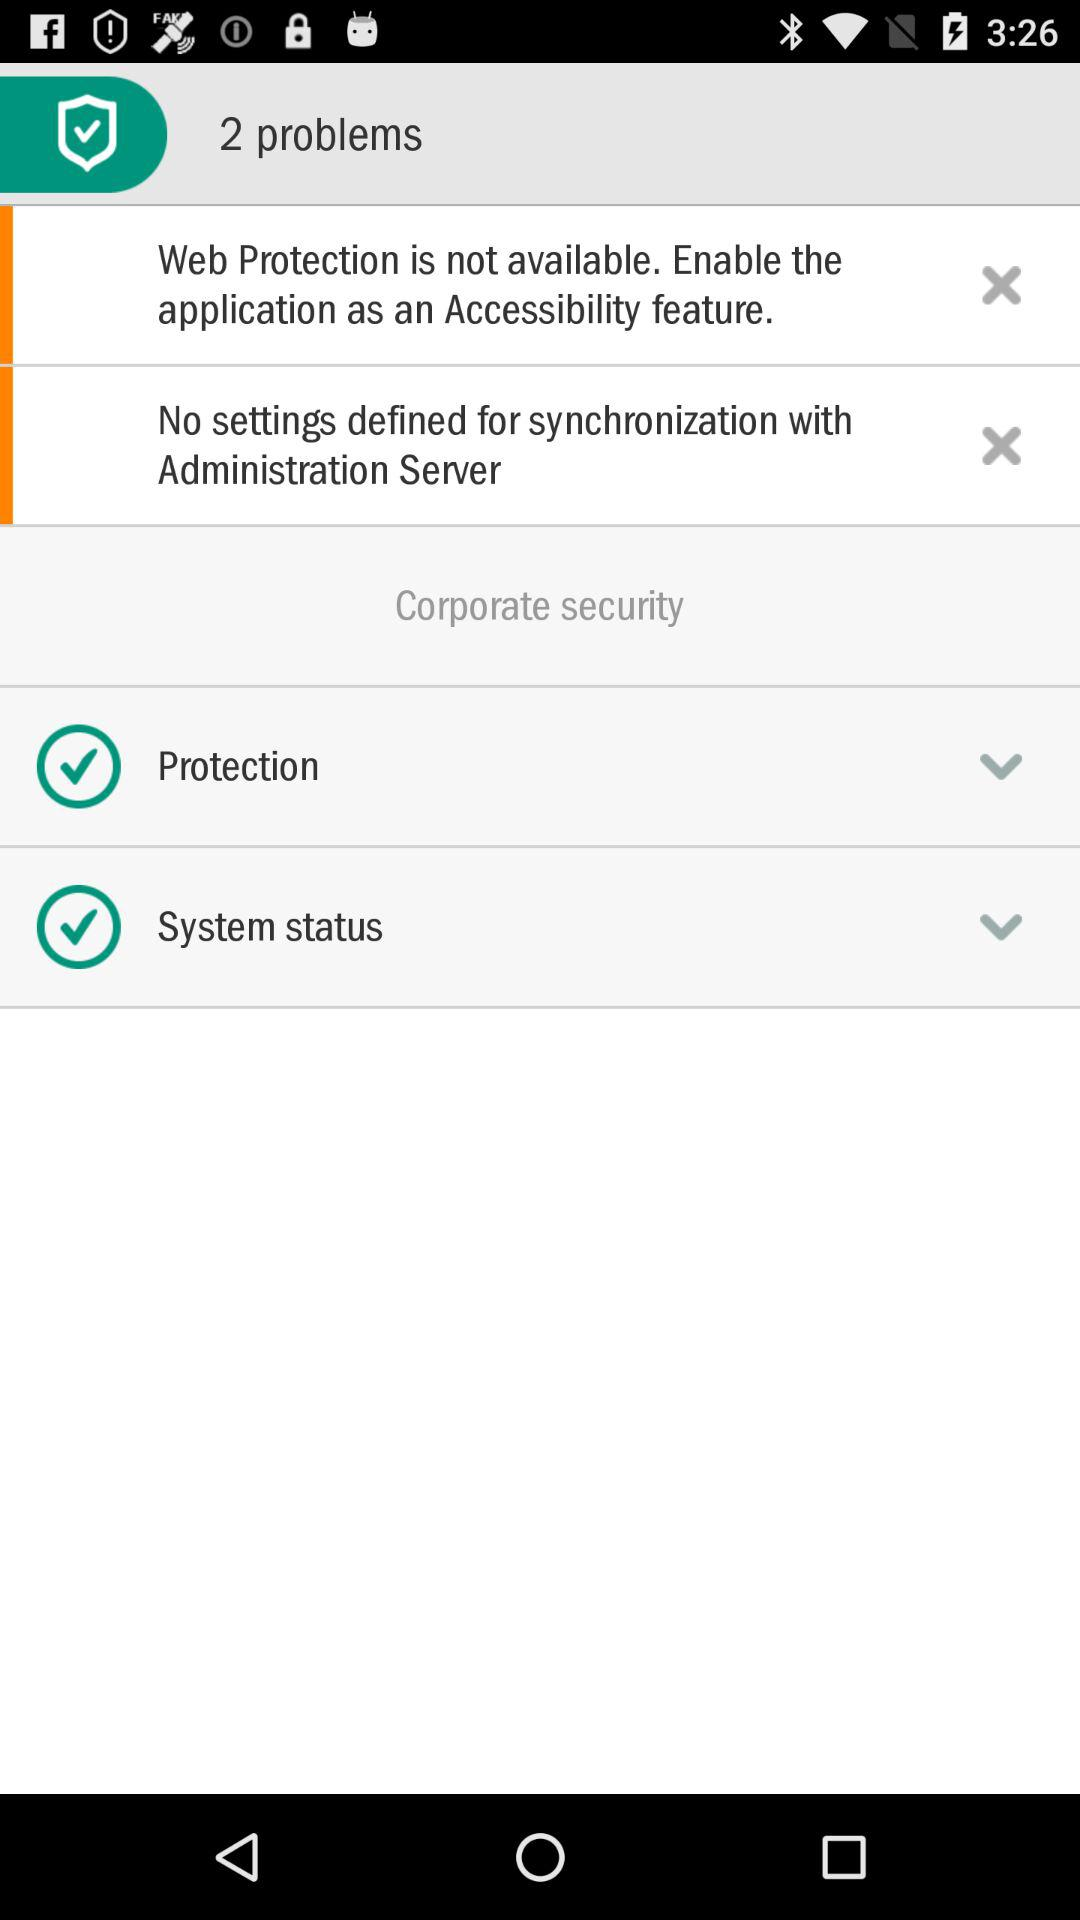How many problems are there in total?
Answer the question using a single word or phrase. 2 